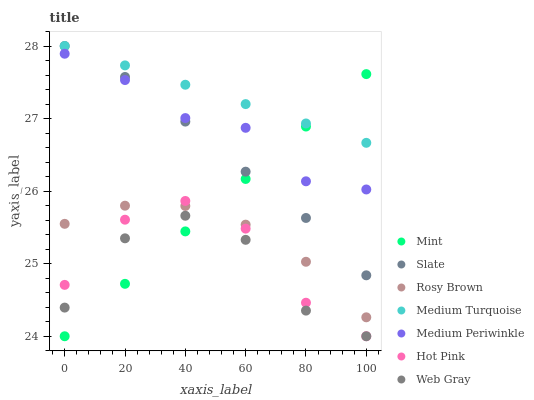Does Web Gray have the minimum area under the curve?
Answer yes or no. Yes. Does Medium Turquoise have the maximum area under the curve?
Answer yes or no. Yes. Does Slate have the minimum area under the curve?
Answer yes or no. No. Does Slate have the maximum area under the curve?
Answer yes or no. No. Is Mint the smoothest?
Answer yes or no. Yes. Is Web Gray the roughest?
Answer yes or no. Yes. Is Slate the smoothest?
Answer yes or no. No. Is Slate the roughest?
Answer yes or no. No. Does Hot Pink have the lowest value?
Answer yes or no. Yes. Does Slate have the lowest value?
Answer yes or no. No. Does Medium Turquoise have the highest value?
Answer yes or no. Yes. Does Rosy Brown have the highest value?
Answer yes or no. No. Is Hot Pink less than Medium Turquoise?
Answer yes or no. Yes. Is Slate greater than Web Gray?
Answer yes or no. Yes. Does Mint intersect Slate?
Answer yes or no. Yes. Is Mint less than Slate?
Answer yes or no. No. Is Mint greater than Slate?
Answer yes or no. No. Does Hot Pink intersect Medium Turquoise?
Answer yes or no. No. 